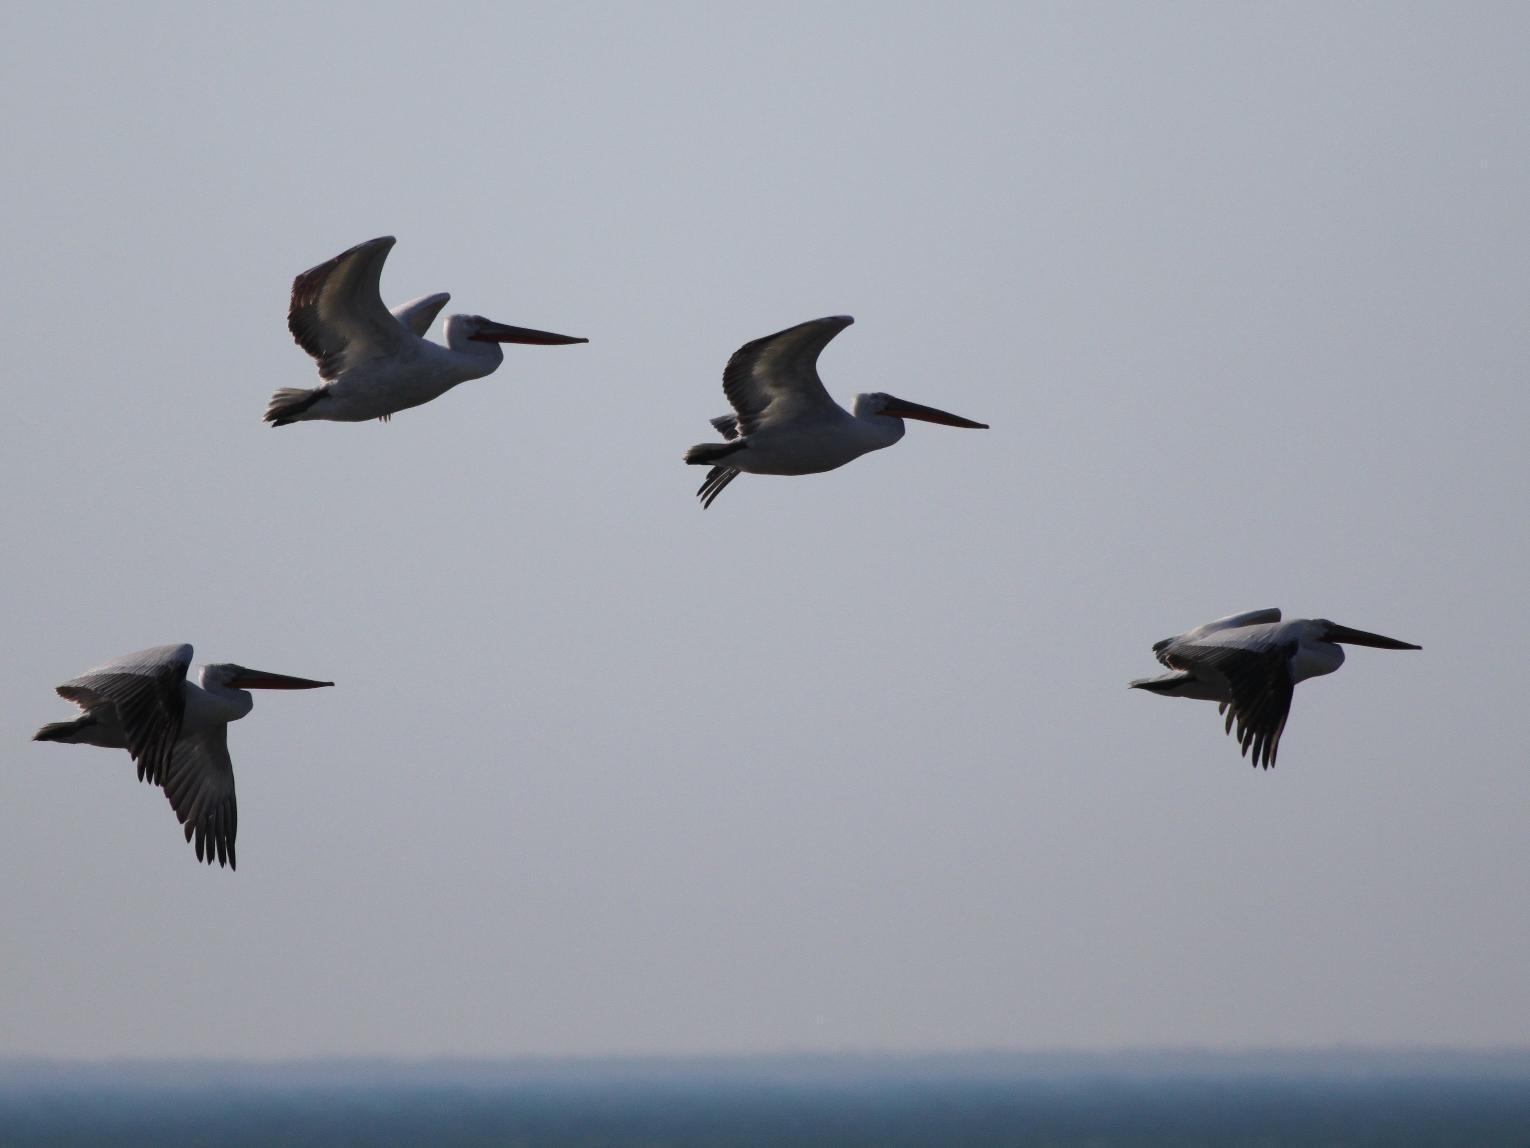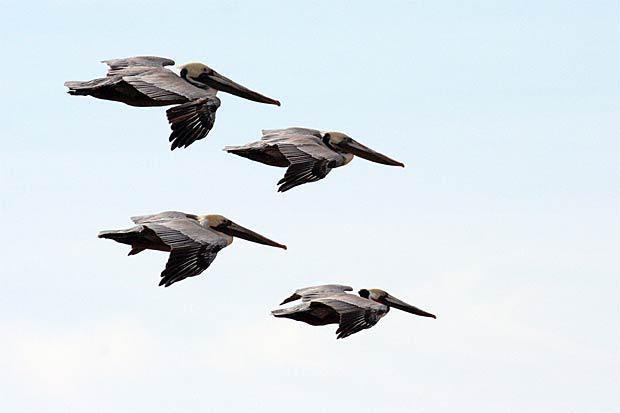The first image is the image on the left, the second image is the image on the right. Given the left and right images, does the statement "All of the birds in both images are flying rightward." hold true? Answer yes or no. Yes. The first image is the image on the left, the second image is the image on the right. For the images shown, is this caption "Two birds are flying to the left in the image on the left." true? Answer yes or no. No. 